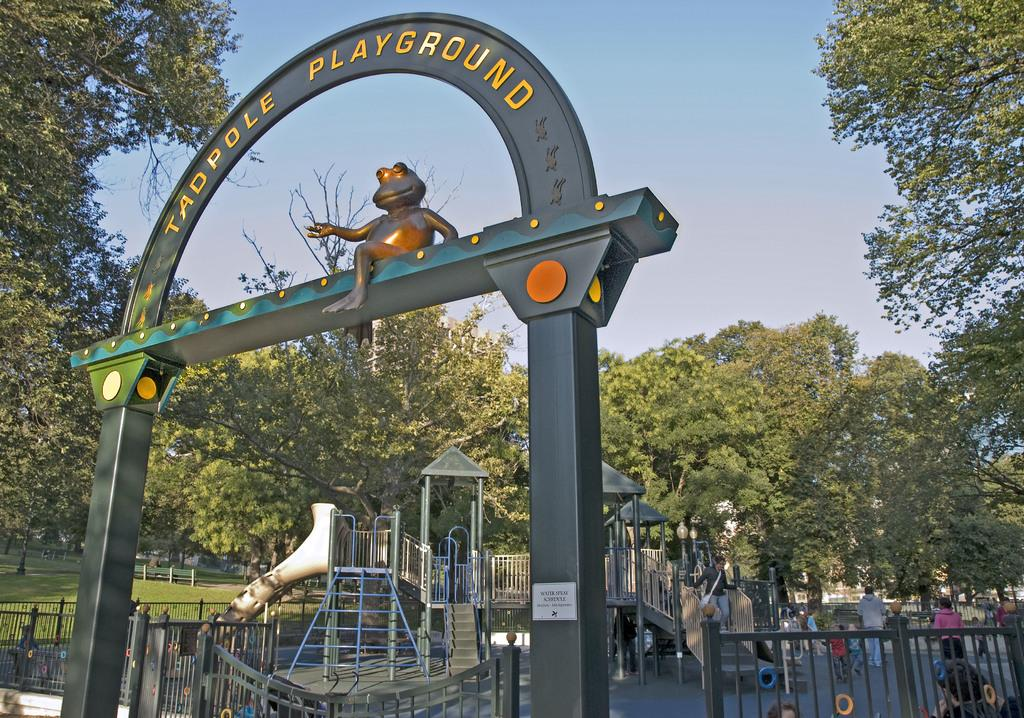What type of barrier can be seen in the image? There is a fence in the image. What type of vegetation is present in the image? There are trees and grass in the image. What architectural feature is visible in the image? There is an arch in the image. What are the people in the image doing? There is a group of people on the ground in the image. What can be seen in the background of the image? The sky is visible in the background of the image. How many minutes does it take for the trees to guide the people in the image? There is no indication in the image that the trees are guiding the people, nor is there any mention of time. 